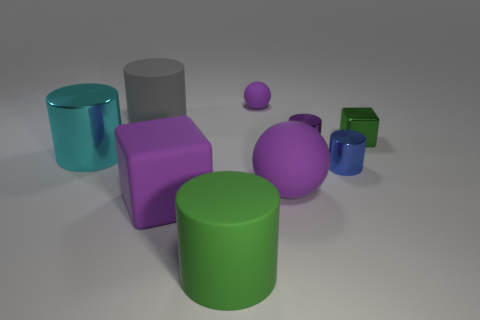Which objects in the image seem to be of the same material? All objects in the image appear to have a similar smooth and reflective material quality, suggesting that they might be made of the same, or similar, types of materials. 